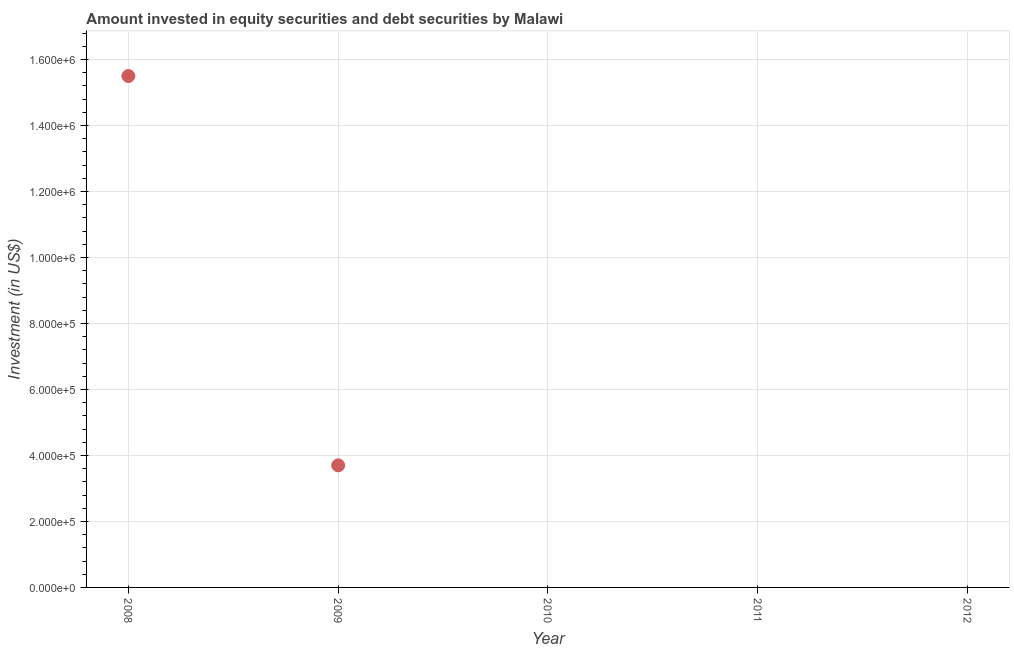What is the portfolio investment in 2011?
Provide a succinct answer. 0. Across all years, what is the maximum portfolio investment?
Provide a short and direct response. 1.55e+06. In which year was the portfolio investment maximum?
Your answer should be compact. 2008. What is the sum of the portfolio investment?
Offer a terse response. 1.92e+06. What is the average portfolio investment per year?
Offer a terse response. 3.84e+05. In how many years, is the portfolio investment greater than 640000 US$?
Ensure brevity in your answer.  1. Is the difference between the portfolio investment in 2008 and 2009 greater than the difference between any two years?
Offer a terse response. No. What is the difference between the highest and the lowest portfolio investment?
Your answer should be very brief. 1.55e+06. In how many years, is the portfolio investment greater than the average portfolio investment taken over all years?
Your response must be concise. 1. Does the portfolio investment monotonically increase over the years?
Give a very brief answer. No. How many years are there in the graph?
Keep it short and to the point. 5. Are the values on the major ticks of Y-axis written in scientific E-notation?
Provide a succinct answer. Yes. Does the graph contain grids?
Your response must be concise. Yes. What is the title of the graph?
Your answer should be very brief. Amount invested in equity securities and debt securities by Malawi. What is the label or title of the X-axis?
Your response must be concise. Year. What is the label or title of the Y-axis?
Offer a very short reply. Investment (in US$). What is the Investment (in US$) in 2008?
Your answer should be very brief. 1.55e+06. What is the Investment (in US$) in 2009?
Your answer should be compact. 3.70e+05. What is the Investment (in US$) in 2012?
Keep it short and to the point. 0. What is the difference between the Investment (in US$) in 2008 and 2009?
Make the answer very short. 1.18e+06. What is the ratio of the Investment (in US$) in 2008 to that in 2009?
Ensure brevity in your answer.  4.19. 